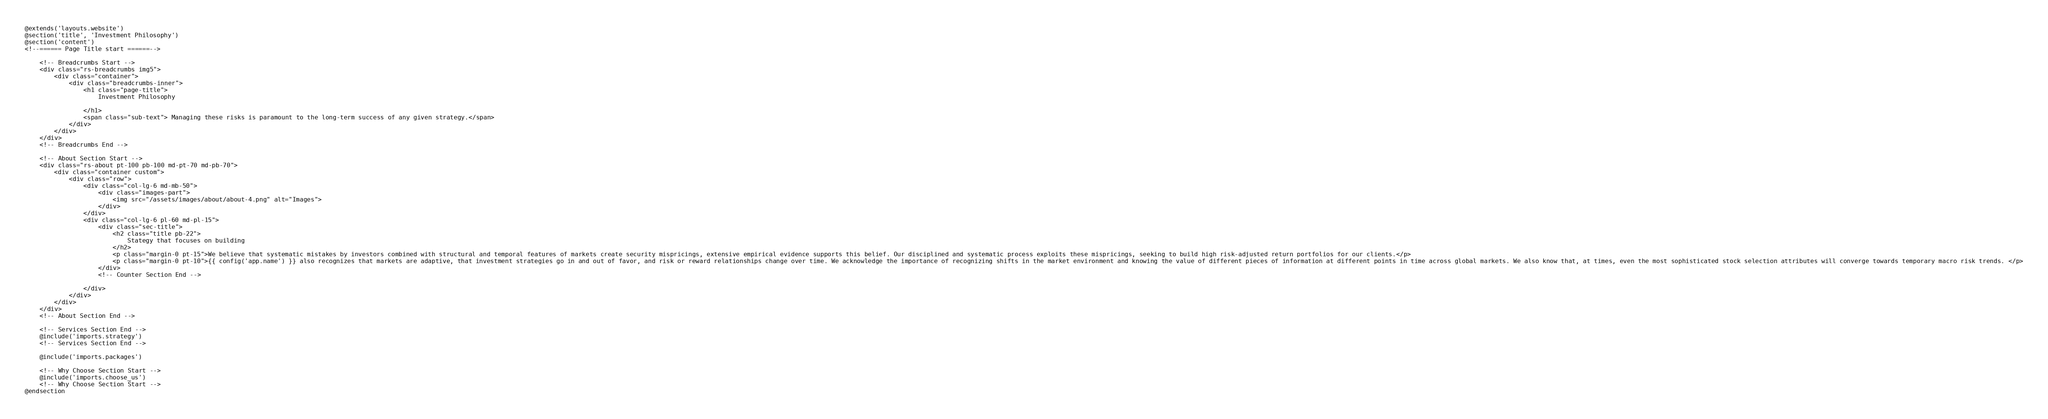<code> <loc_0><loc_0><loc_500><loc_500><_PHP_>@extends('layouts.website')
@section('title', 'Investment Philosophy')
@section('content')
<!--====== Page Title start ======-->
   
    <!-- Breadcrumbs Start -->
    <div class="rs-breadcrumbs img5">
        <div class="container">
            <div class="breadcrumbs-inner">
                <h1 class="page-title">
                    Investment Philosophy
                    
                </h1>
                <span class="sub-text"> Managing these risks is paramount to the long-term success of any given strategy.</span>
            </div>
        </div>
    </div>
    <!-- Breadcrumbs End -->

    <!-- About Section Start -->
    <div class="rs-about pt-100 pb-100 md-pt-70 md-pb-70">
        <div class="container custom">
            <div class="row">
                <div class="col-lg-6 md-mb-50">
                    <div class="images-part">
                        <img src="/assets/images/about/about-4.png" alt="Images">
                    </div>
                </div>
                <div class="col-lg-6 pl-60 md-pl-15">
                    <div class="sec-title">
                        <h2 class="title pb-22">
                            Stategy that focuses on building
                        </h2>
                        <p class="margin-0 pt-15">We believe that systematic mistakes by investors combined with structural and temporal features of markets create security mispricings, extensive empirical evidence supports this belief. Our disciplined and systematic process exploits these mispricings, seeking to build high risk-adjusted return portfolios for our clients.</p>
                        <p class="margin-0 pt-10">{{ config('app.name') }} also recognizes that markets are adaptive, that investment strategies go in and out of favor, and risk or reward relationships change over time. We acknowledge the importance of recognizing shifts in the market environment and knowing the value of different pieces of information at different points in time across global markets. We also know that, at times, even the most sophisticated stock selection attributes will converge towards temporary macro risk trends. </p>
                    </div>
                    <!-- Counter Section End -->
                    
                </div>
            </div>
        </div>
    </div>
    <!-- About Section End -->

    <!-- Services Section End -->
    @include('imports.strategy')
    <!-- Services Section End -->

    @include('imports.packages')

    <!-- Why Choose Section Start -->
    @include('imports.choose_us')
    <!-- Why Choose Section Start -->      
@endsection</code> 